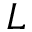<formula> <loc_0><loc_0><loc_500><loc_500>L</formula> 